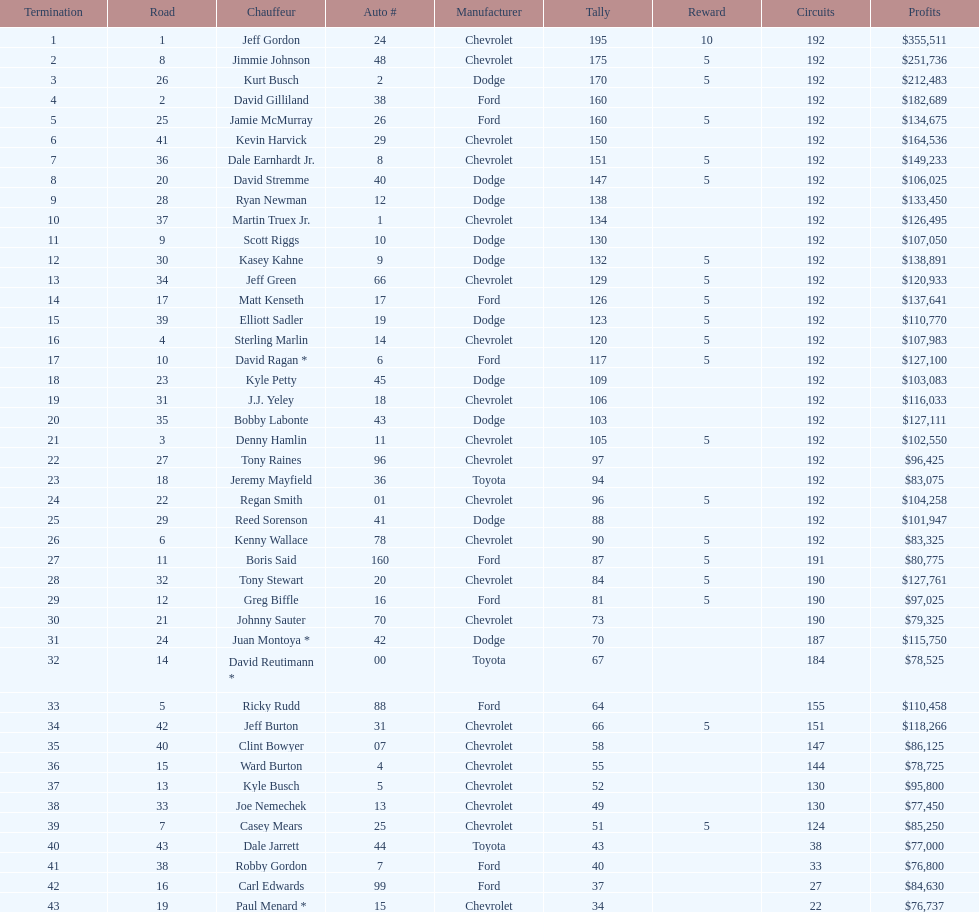Who is first in number of winnings on this list? Jeff Gordon. 